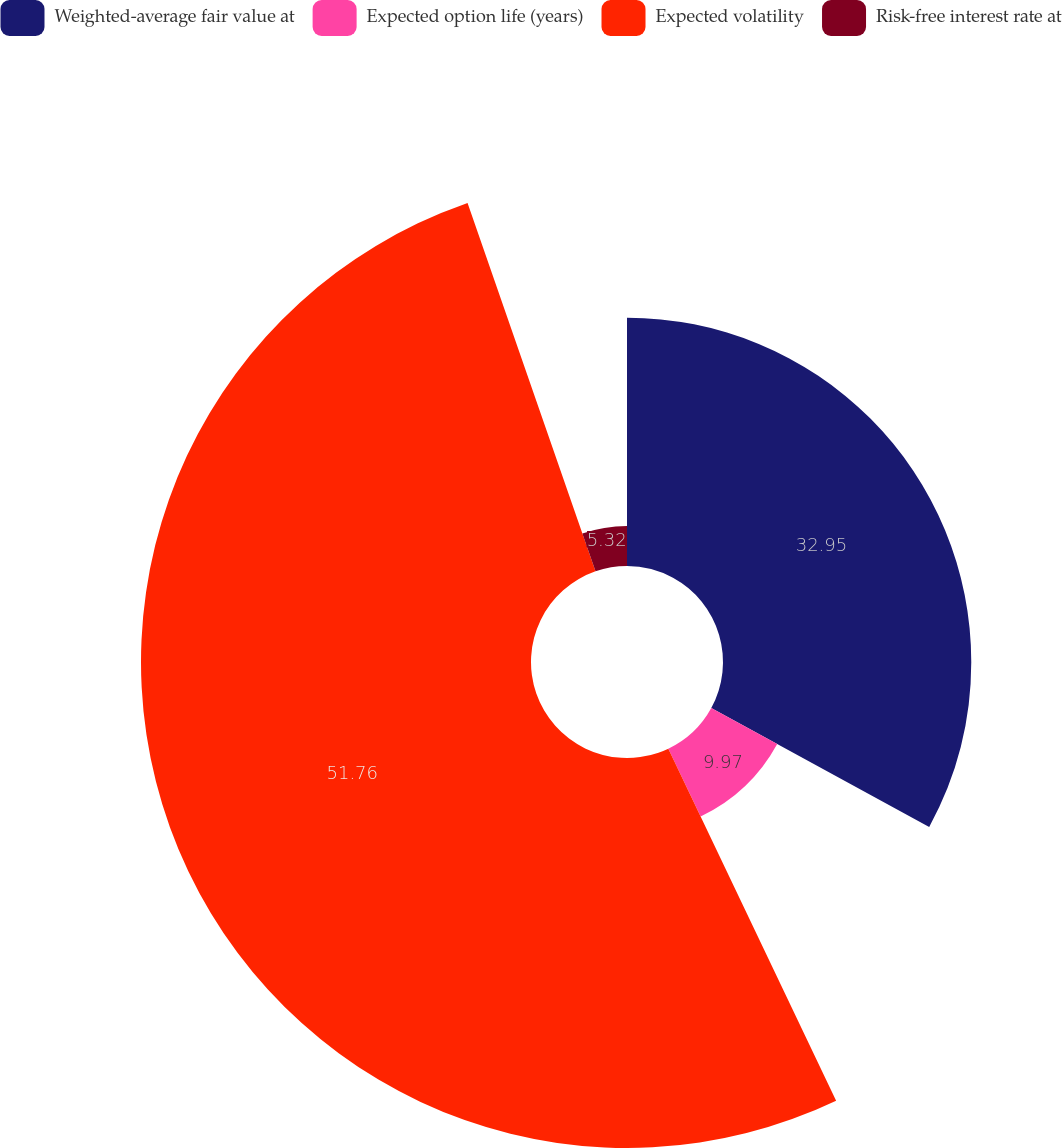<chart> <loc_0><loc_0><loc_500><loc_500><pie_chart><fcel>Weighted-average fair value at<fcel>Expected option life (years)<fcel>Expected volatility<fcel>Risk-free interest rate at<nl><fcel>32.95%<fcel>9.97%<fcel>51.76%<fcel>5.32%<nl></chart> 